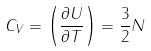Convert formula to latex. <formula><loc_0><loc_0><loc_500><loc_500>C _ { V } = \left ( { \frac { \partial U } { \partial T } } \right ) = { \frac { 3 } { 2 } } N</formula> 